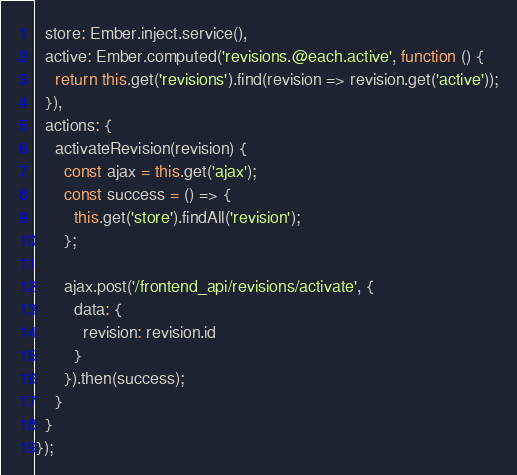Convert code to text. <code><loc_0><loc_0><loc_500><loc_500><_JavaScript_>  store: Ember.inject.service(),
  active: Ember.computed('revisions.@each.active', function () {
    return this.get('revisions').find(revision => revision.get('active'));
  }),
  actions: {
    activateRevision(revision) {
      const ajax = this.get('ajax');
      const success = () => {
        this.get('store').findAll('revision');
      };

      ajax.post('/frontend_api/revisions/activate', {
        data: {
          revision: revision.id
        }
      }).then(success);
    }
  }
});
</code> 